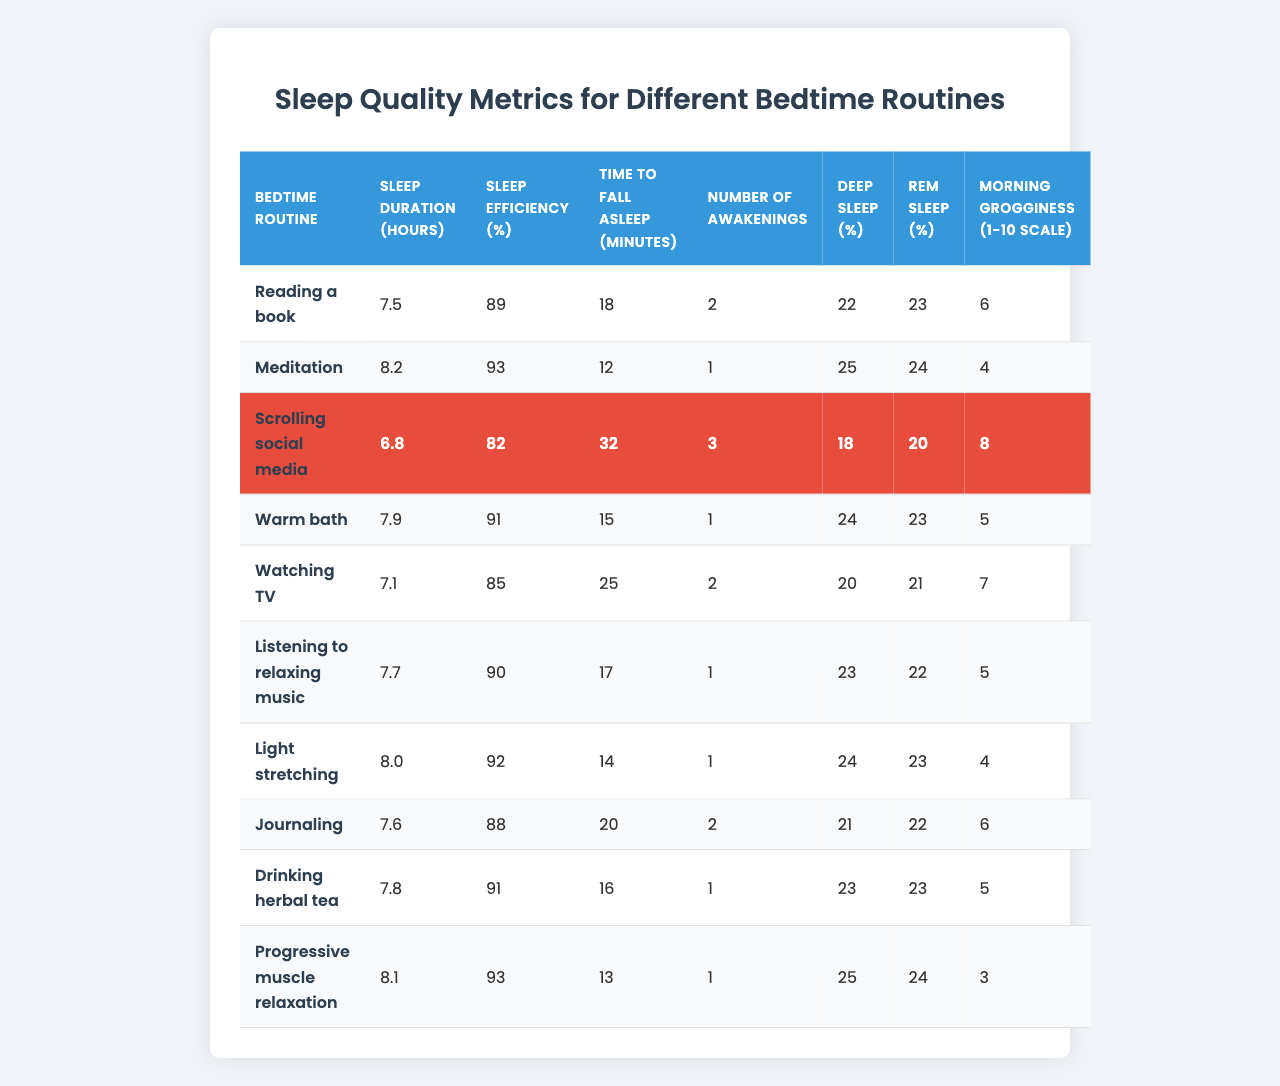What is the sleep duration for the meditation bedtime routine? According to the table, the sleep duration listed for the meditation bedtime routine is 8.2 hours.
Answer: 8.2 hours Which bedtime routine has the highest sleep efficiency? By examining the table, 'Meditation' and 'Progressive muscle relaxation' both have the highest sleep efficiency at 93%.
Answer: Meditation and Progressive muscle relaxation How much deeper sleep (percentage) do you get from light stretching compared to scrolling social media? Light stretching has 24% deep sleep and scrolling social media has 18%. The difference is 24% - 18% = 6%.
Answer: 6% Is it true that watching TV leads to more awakenings than reading a book? Yes, watching TV has 2 awakenings while reading a book has 2 awakenings too; both are equal, so the statement is false.
Answer: No What is the average sleep duration across all bedtime routines? To calculate the average, sum the sleep durations (7.5 + 8.2 + 6.8 + 7.9 + 7.1 + 7.7 + 8.0 + 7.6 + 7.8 + 8.1 = 80.7) and divide by 10, which gives 80.7 / 10 = 8.07 hours.
Answer: 8.07 hours Which bedtime routine leads to the lowest morning grogginess? By comparing the table, 'Progressive muscle relaxation' has the lowest morning grogginess rating of 3 on a scale of 1 to 10.
Answer: Progressive muscle relaxation How many total awakenings are recorded for all routines combined? By adding the number of awakenings from each routine (2 + 1 + 3 + 1 + 2 + 1 + 1 + 2 + 1 + 1 = 15), the total is 15 awakenings.
Answer: 15 awakenings Which routines have a sleep efficiency below 85%? Looking at the table, 'Scrolling social media' (82%) and 'Watching TV' (85%) have sleep efficiency below 85%; hence, the answer includes only scrolling social media.
Answer: Scrolling social media What is the relationship between sleep duration and morning grogginess based on the table data? By analyzing the data, as sleep duration increases, morning grogginess generally decreases, indicating that longer sleep duration may correlate to less grogginess.
Answer: Generally negative correlation Calculate the total percentage of REM sleep for the routines that improved sleep efficiency above 90%. The routines with over 90% sleep efficiency are 'Meditation' (24%) and 'Progressive muscle relaxation' (24%), totaling (24 + 24 = 48%) REM sleep across both.
Answer: 48% 